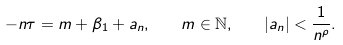<formula> <loc_0><loc_0><loc_500><loc_500>- n \tau = m + \beta _ { 1 } + a _ { n } , \quad m \in \mathbb { N } , \quad | a _ { n } | < \frac { 1 } { n ^ { \rho } } .</formula> 